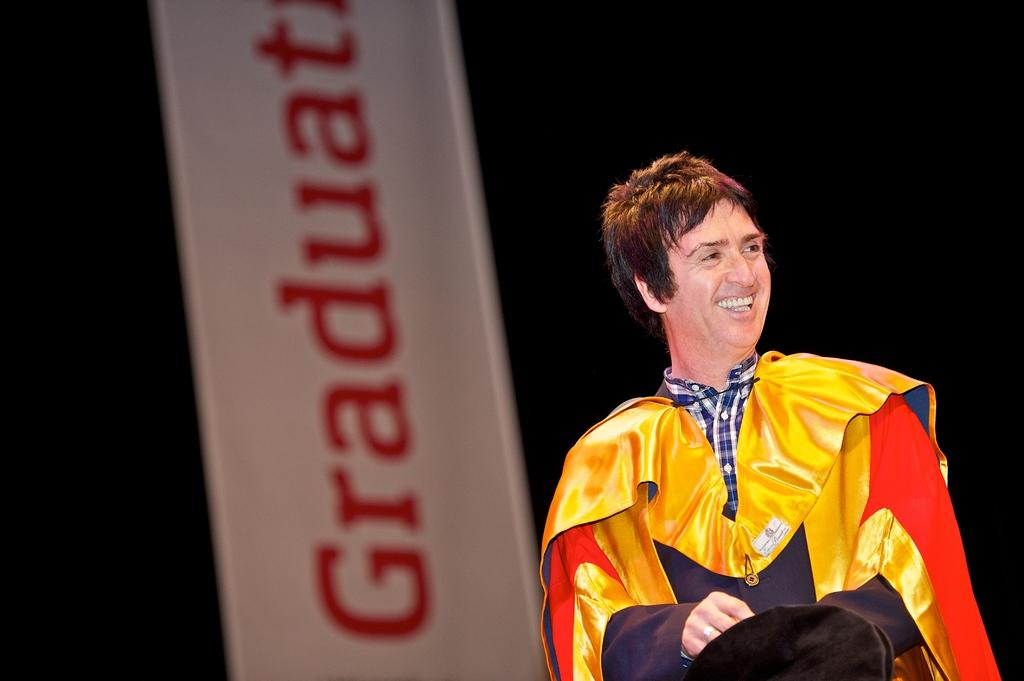What is located on the right side of the image? There is a man on the right side of the image. What is the man wearing in the image? The man is wearing a dress in the image. What expression does the man have in the image? The man is smiling in the image. What can be seen in the background of the image? There is a board visible in the background of the image. What type of shame is the man feeling in the image? There is no indication of shame in the image; the man is smiling. What guide is the man using to navigate in the image? There is no guide present in the image; the man is simply standing on the right side. 